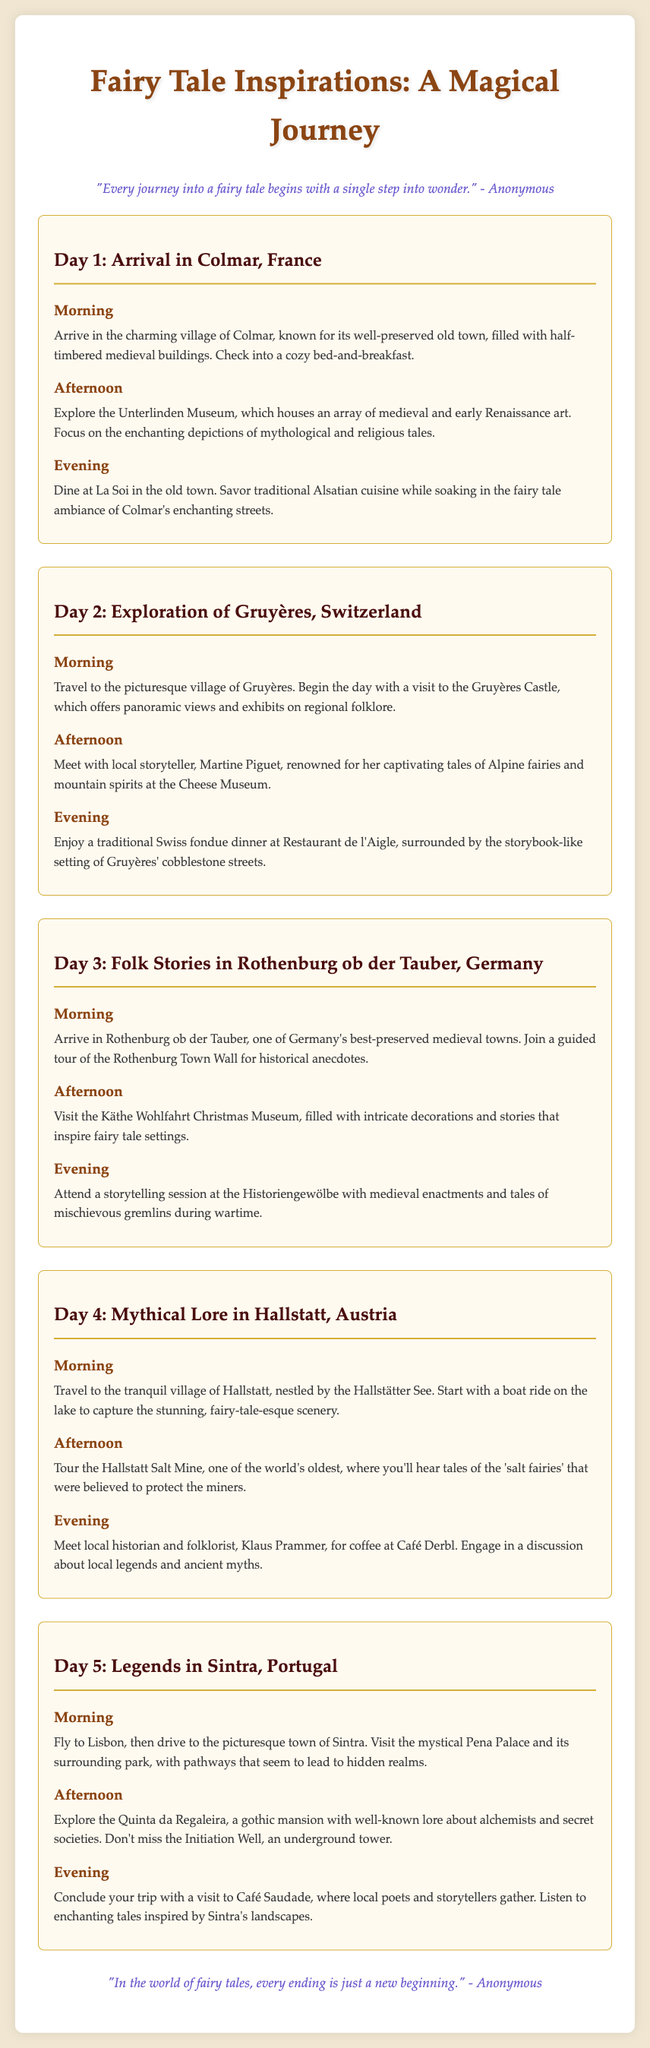What is the title of the itinerary? The title of the itinerary is prominently displayed at the top of the document.
Answer: Fairy Tale Inspirations: A Magical Journey How many days does the itinerary cover? The document outlines activities for a total of five days.
Answer: 5 What village is featured on Day 1? The itinerary specifies the charming village visited on Day 1.
Answer: Colmar Who is the local storyteller met in Gruyères? The document mentions a specific local storyteller known for alpine tales.
Answer: Martine Piguet What evening activity is planned for Day 3? The evening activity for Day 3 includes a specific type of presentation related to folklore.
Answer: Storytelling session What type of dinner is served in Gruyères on Day 2? The itinerary describes the dinner style for the evening in Gruyères.
Answer: Swiss fondue What museum is visited in Rothenburg ob der Tauber during the afternoon? The document lists an attraction that celebrates Christmas-related stories.
Answer: Käthe Wohlfahrt Christmas Museum What is the last location mentioned in the itinerary? The itinerary concludes with a specific place where local poets gather.
Answer: Café Saudade 